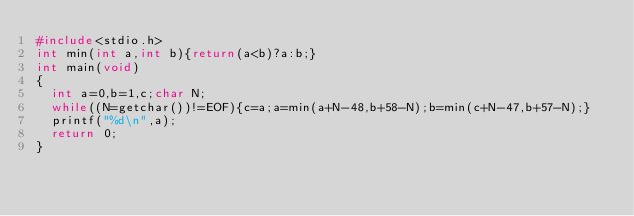<code> <loc_0><loc_0><loc_500><loc_500><_C_>#include<stdio.h>
int min(int a,int b){return(a<b)?a:b;}
int main(void)
{
  int a=0,b=1,c;char N;
  while((N=getchar())!=EOF){c=a;a=min(a+N-48,b+58-N);b=min(c+N-47,b+57-N);}
  printf("%d\n",a);
  return 0;
}</code> 